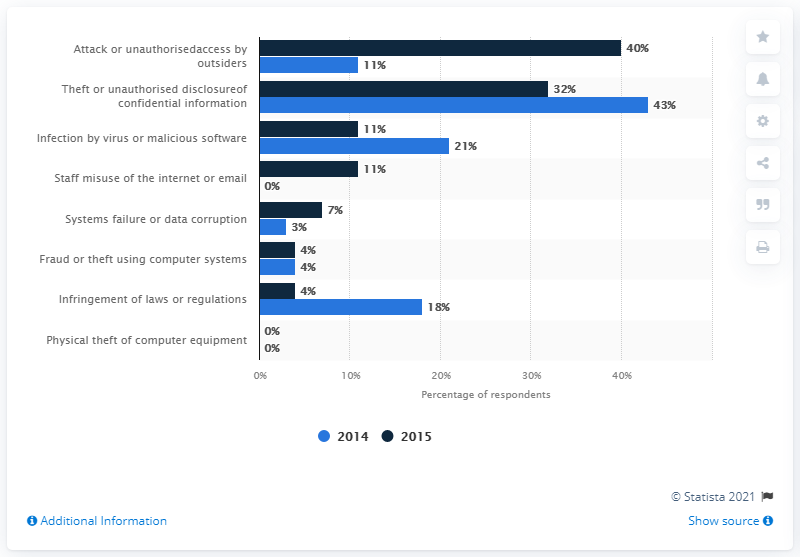Point out several critical features in this image. Fraud and theft using computer systems had the same level of security risk in 2014 and 2015. The ratio of fraud or theft using computer systems to physical theft of computer equipment is 4:00. 